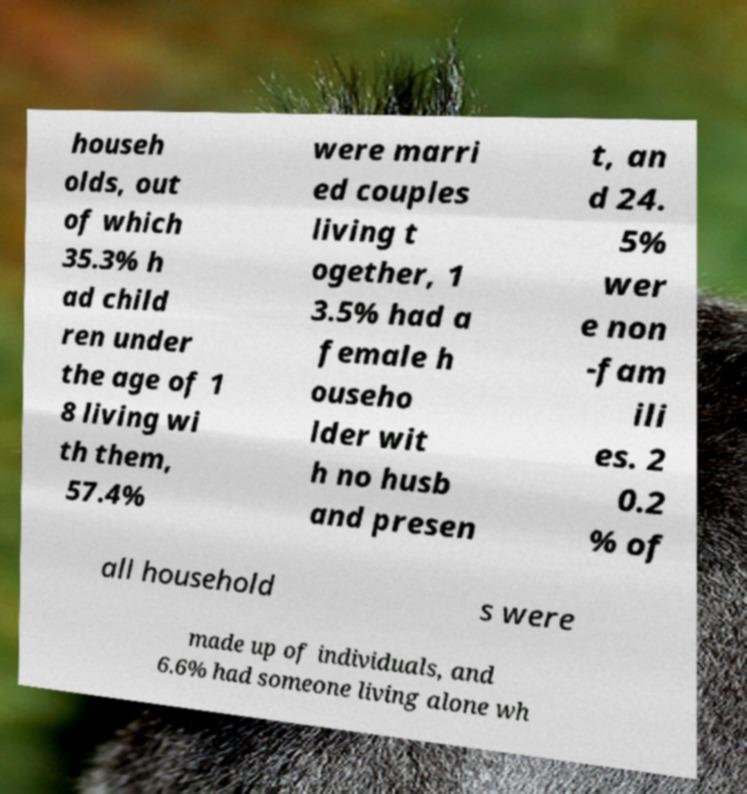There's text embedded in this image that I need extracted. Can you transcribe it verbatim? househ olds, out of which 35.3% h ad child ren under the age of 1 8 living wi th them, 57.4% were marri ed couples living t ogether, 1 3.5% had a female h ouseho lder wit h no husb and presen t, an d 24. 5% wer e non -fam ili es. 2 0.2 % of all household s were made up of individuals, and 6.6% had someone living alone wh 